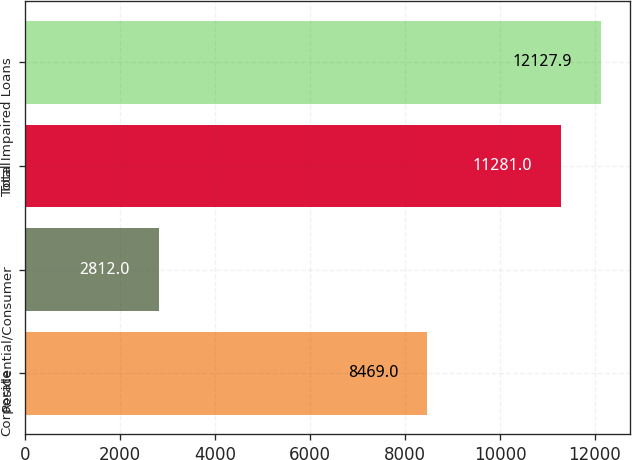Convert chart. <chart><loc_0><loc_0><loc_500><loc_500><bar_chart><fcel>Corporate<fcel>Residential/Consumer<fcel>Total<fcel>Total Impaired Loans<nl><fcel>8469<fcel>2812<fcel>11281<fcel>12127.9<nl></chart> 